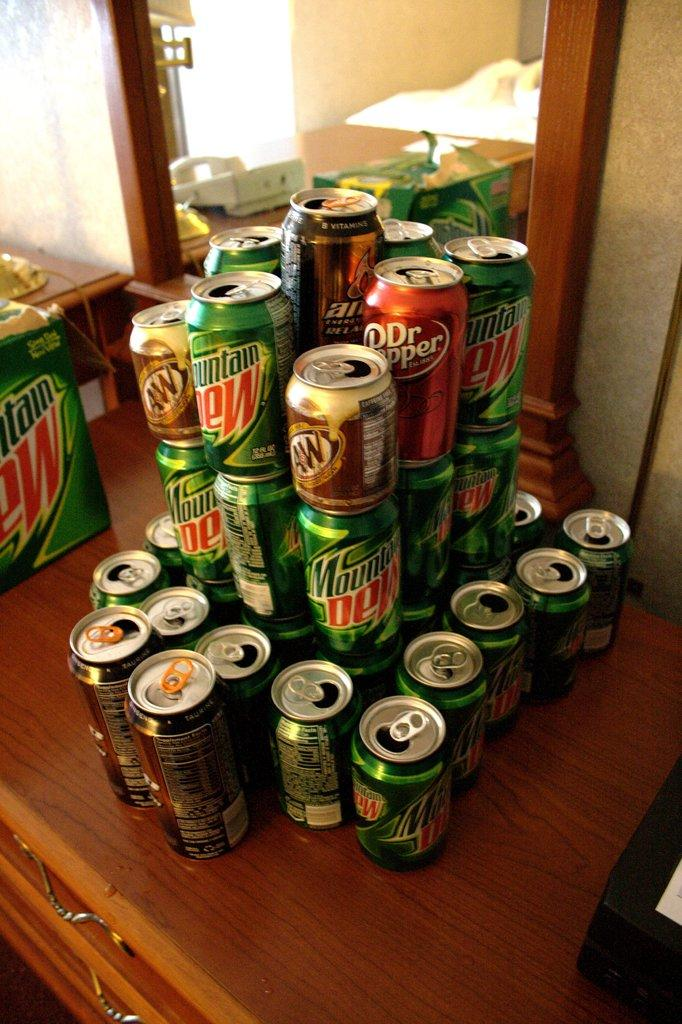<image>
Render a clear and concise summary of the photo. A stack of Dr. Pepper, Mountain Dew, and AW soda cans. 